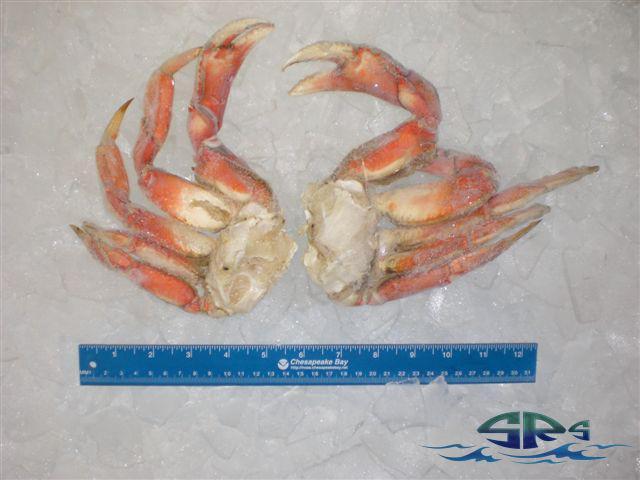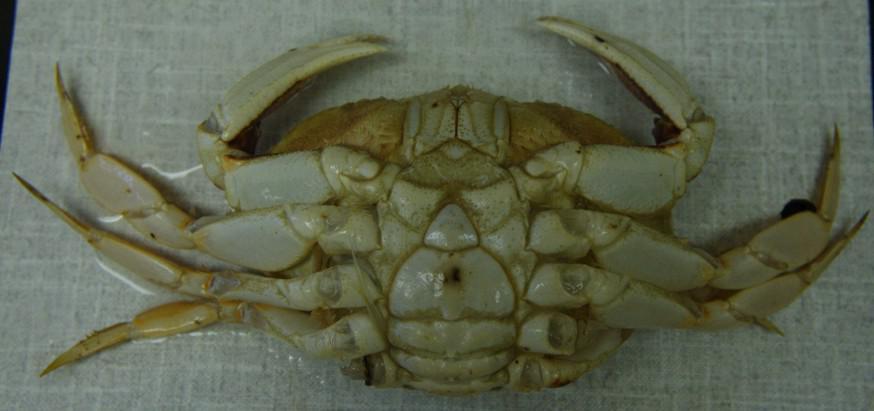The first image is the image on the left, the second image is the image on the right. Given the left and right images, does the statement "The left image shows one clear plastic wrapper surrounding red-orange crab claws, and the right image shows multiple individually plastic wrapped crabs." hold true? Answer yes or no. No. The first image is the image on the left, the second image is the image on the right. Considering the images on both sides, is "A ruler depicts the size of a crab." valid? Answer yes or no. Yes. 